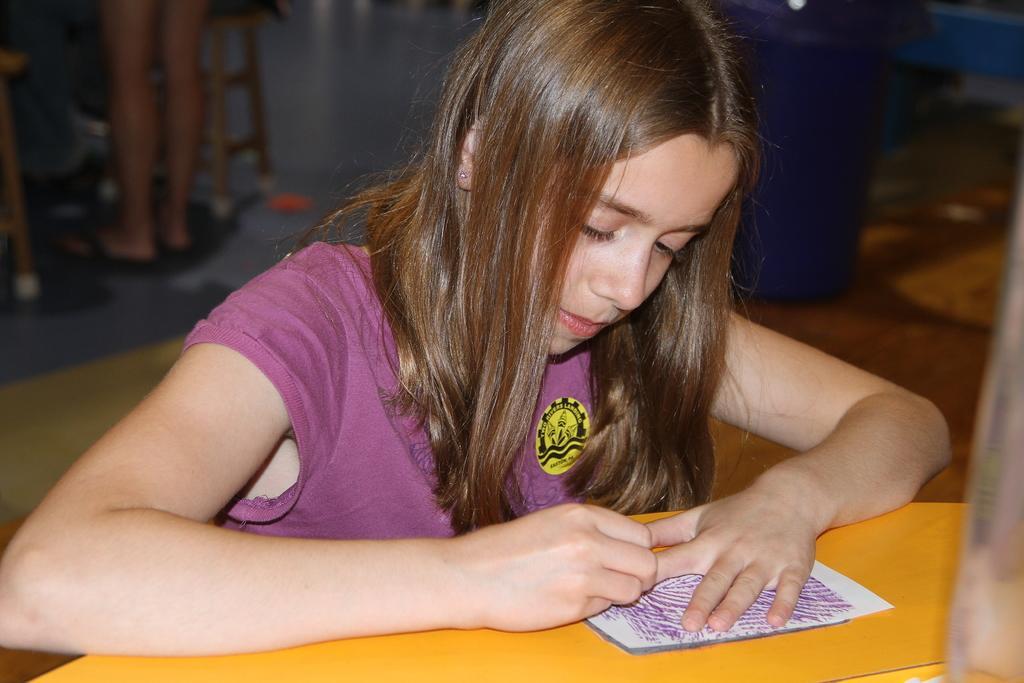Describe this image in one or two sentences. In this image I can see a girl wearing pink colored dress is in front of a yellow colored desk and I can see she is writing something on the paper. I can see the blurry background in which I can see a person standing, a stool, a blue colored object and few other objects. 